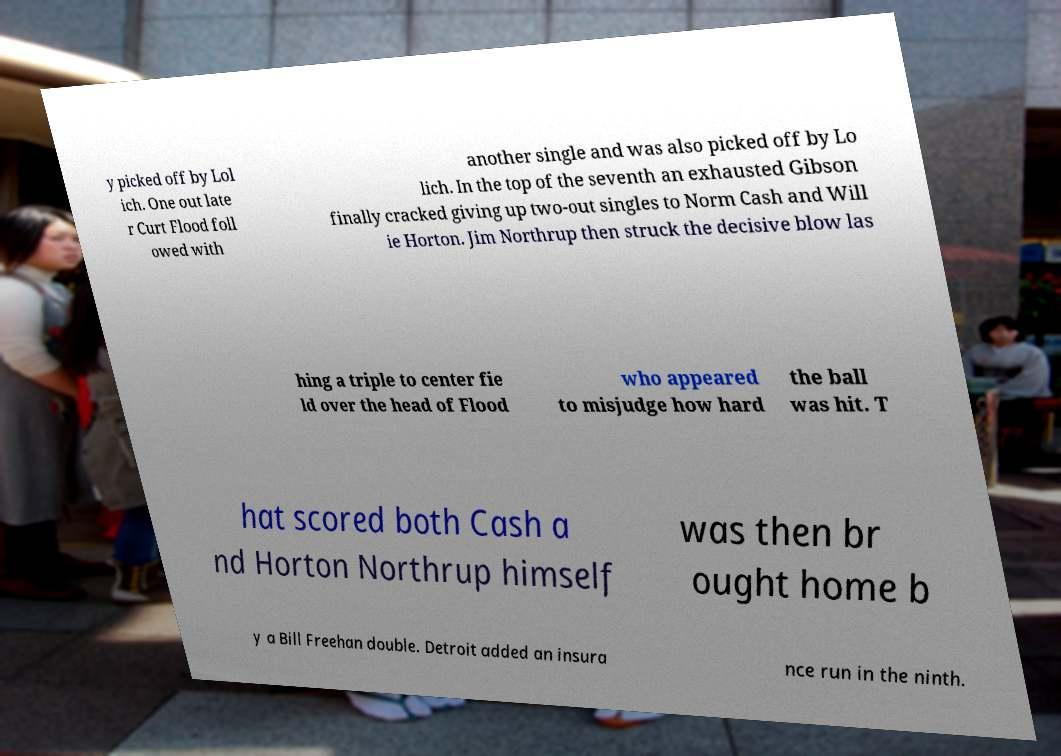Could you assist in decoding the text presented in this image and type it out clearly? y picked off by Lol ich. One out late r Curt Flood foll owed with another single and was also picked off by Lo lich. In the top of the seventh an exhausted Gibson finally cracked giving up two-out singles to Norm Cash and Will ie Horton. Jim Northrup then struck the decisive blow las hing a triple to center fie ld over the head of Flood who appeared to misjudge how hard the ball was hit. T hat scored both Cash a nd Horton Northrup himself was then br ought home b y a Bill Freehan double. Detroit added an insura nce run in the ninth. 